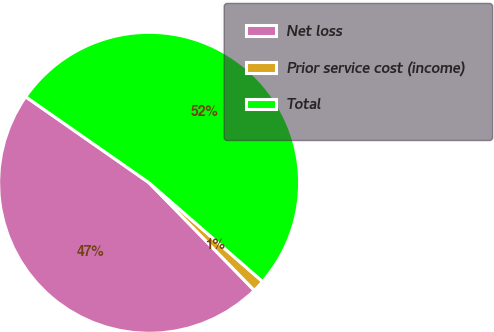Convert chart to OTSL. <chart><loc_0><loc_0><loc_500><loc_500><pie_chart><fcel>Net loss<fcel>Prior service cost (income)<fcel>Total<nl><fcel>47.01%<fcel>1.28%<fcel>51.71%<nl></chart> 